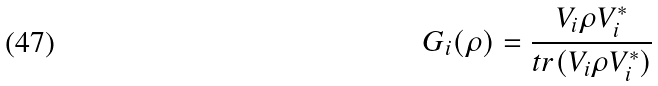Convert formula to latex. <formula><loc_0><loc_0><loc_500><loc_500>G _ { i } ( \rho ) = \frac { V _ { i } \rho V _ { i } ^ { * } } { t r ( V _ { i } \rho V _ { i } ^ { * } ) }</formula> 